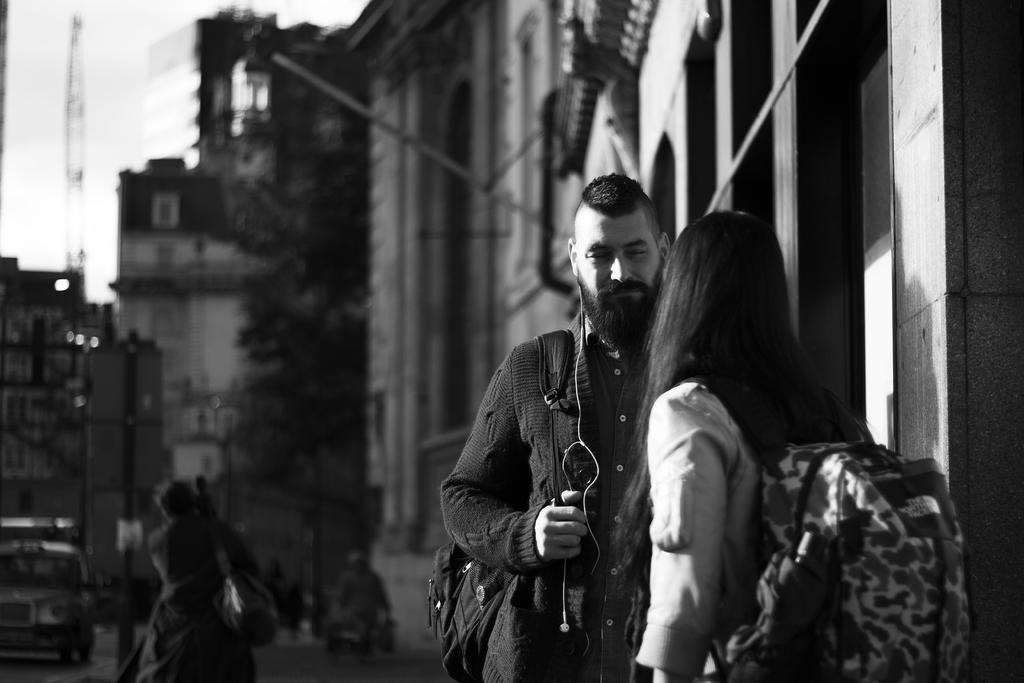How would you summarize this image in a sentence or two? This is a black and white image. I can see the man and woman holding the bag and standing. These are the buildings. I can see another person standing. On the left side of the image, I can see a car on the road. This looks like a pole. In the background, I think this is a tree. 